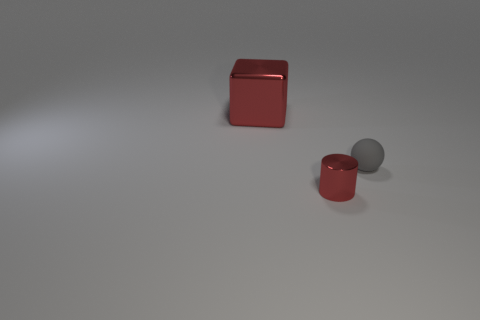Add 2 gray matte balls. How many objects exist? 5 Subtract all cubes. How many objects are left? 2 Subtract all green cubes. Subtract all cyan spheres. How many cubes are left? 1 Subtract all red rubber objects. Subtract all red metallic cylinders. How many objects are left? 2 Add 1 small red metallic things. How many small red metallic things are left? 2 Add 1 tiny red cylinders. How many tiny red cylinders exist? 2 Subtract 0 purple cylinders. How many objects are left? 3 Subtract 1 blocks. How many blocks are left? 0 